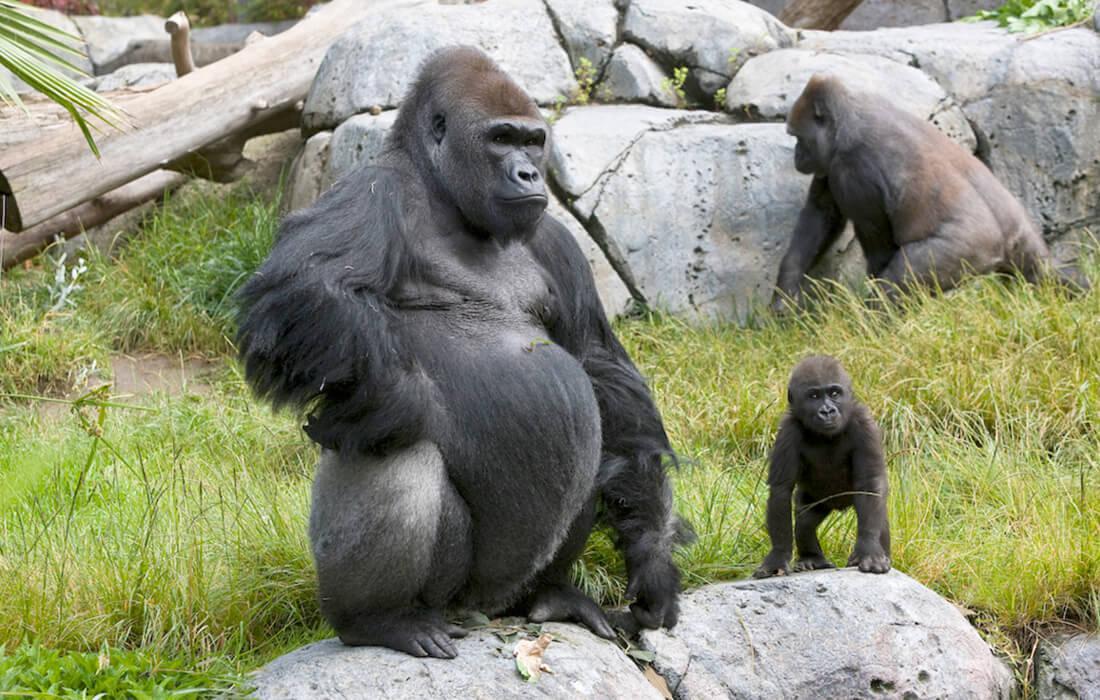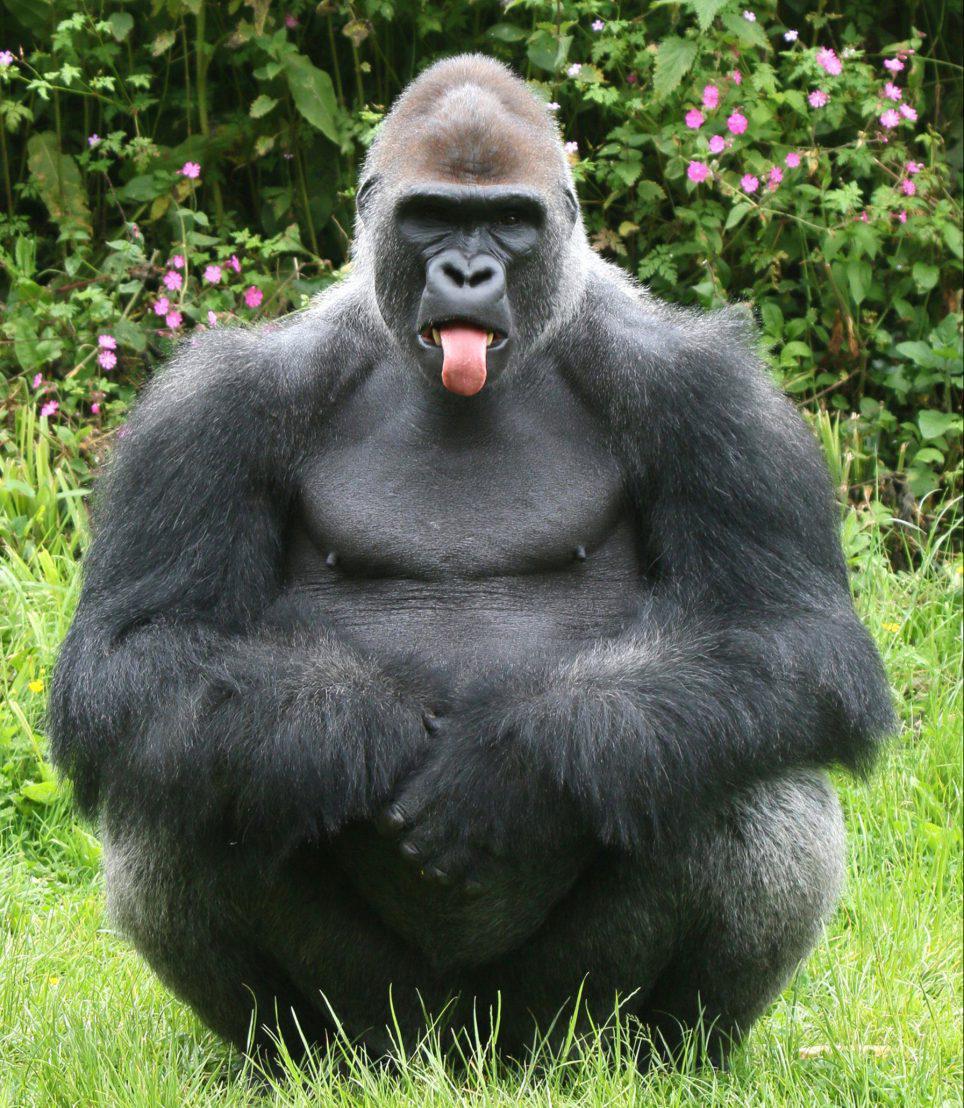The first image is the image on the left, the second image is the image on the right. For the images displayed, is the sentence "There are a total of 2 gorillas in each pair of images." factually correct? Answer yes or no. No. The first image is the image on the left, the second image is the image on the right. For the images shown, is this caption "An image shows a baby gorilla with an adult gorilla." true? Answer yes or no. Yes. 